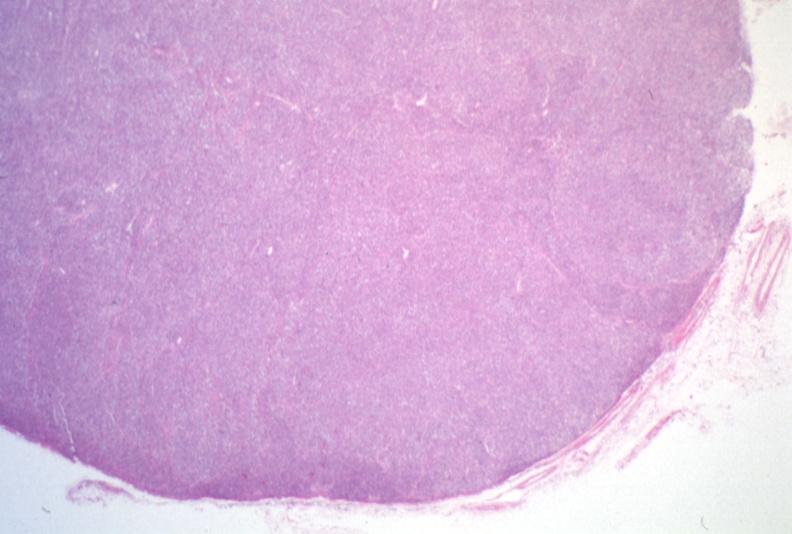does this image show lymph node, lymphoma?
Answer the question using a single word or phrase. Yes 